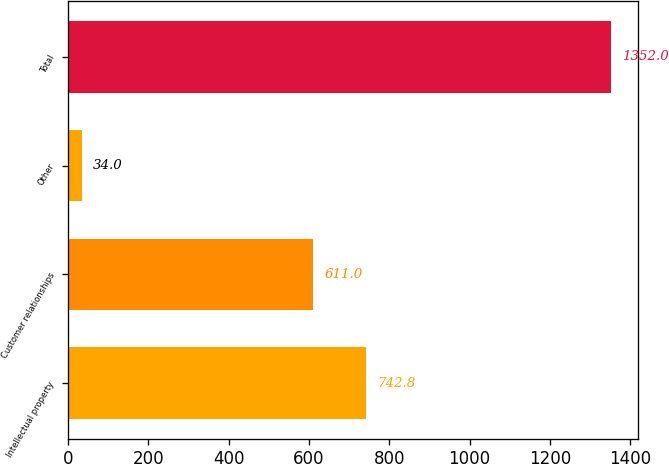Convert chart to OTSL. <chart><loc_0><loc_0><loc_500><loc_500><bar_chart><fcel>Intellectual property<fcel>Customer relationships<fcel>Other<fcel>Total<nl><fcel>742.8<fcel>611<fcel>34<fcel>1352<nl></chart> 